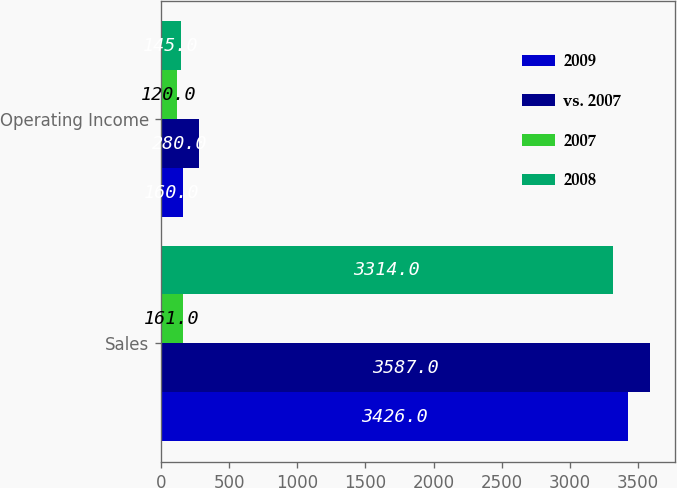<chart> <loc_0><loc_0><loc_500><loc_500><stacked_bar_chart><ecel><fcel>Sales<fcel>Operating Income<nl><fcel>2009<fcel>3426<fcel>160<nl><fcel>vs. 2007<fcel>3587<fcel>280<nl><fcel>2007<fcel>161<fcel>120<nl><fcel>2008<fcel>3314<fcel>145<nl></chart> 